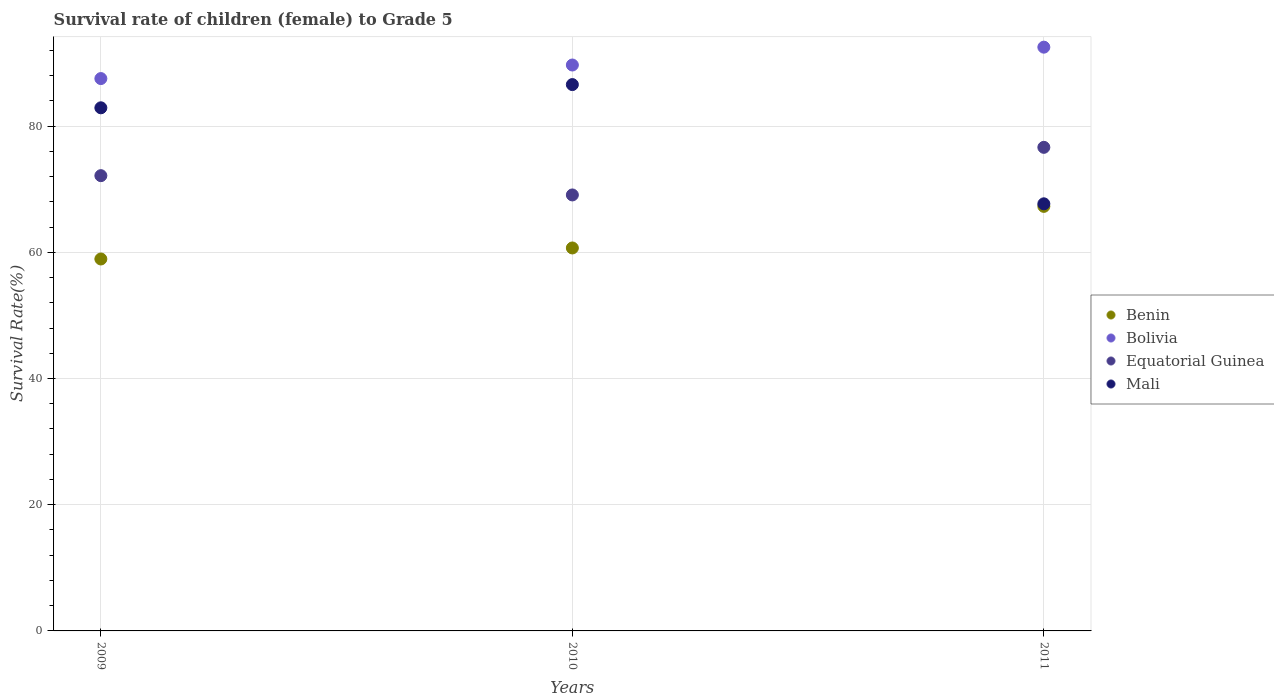What is the survival rate of female children to grade 5 in Bolivia in 2009?
Your answer should be very brief. 87.53. Across all years, what is the maximum survival rate of female children to grade 5 in Equatorial Guinea?
Make the answer very short. 76.63. Across all years, what is the minimum survival rate of female children to grade 5 in Mali?
Ensure brevity in your answer.  67.68. In which year was the survival rate of female children to grade 5 in Mali maximum?
Offer a terse response. 2010. In which year was the survival rate of female children to grade 5 in Mali minimum?
Give a very brief answer. 2011. What is the total survival rate of female children to grade 5 in Equatorial Guinea in the graph?
Provide a succinct answer. 217.86. What is the difference between the survival rate of female children to grade 5 in Mali in 2009 and that in 2010?
Give a very brief answer. -3.68. What is the difference between the survival rate of female children to grade 5 in Benin in 2010 and the survival rate of female children to grade 5 in Equatorial Guinea in 2009?
Your answer should be compact. -11.46. What is the average survival rate of female children to grade 5 in Equatorial Guinea per year?
Your answer should be very brief. 72.62. In the year 2011, what is the difference between the survival rate of female children to grade 5 in Benin and survival rate of female children to grade 5 in Bolivia?
Provide a short and direct response. -25.23. In how many years, is the survival rate of female children to grade 5 in Benin greater than 20 %?
Offer a terse response. 3. What is the ratio of the survival rate of female children to grade 5 in Mali in 2009 to that in 2011?
Your answer should be very brief. 1.22. What is the difference between the highest and the second highest survival rate of female children to grade 5 in Mali?
Provide a short and direct response. 3.68. What is the difference between the highest and the lowest survival rate of female children to grade 5 in Bolivia?
Ensure brevity in your answer.  4.98. Does the survival rate of female children to grade 5 in Benin monotonically increase over the years?
Give a very brief answer. Yes. Are the values on the major ticks of Y-axis written in scientific E-notation?
Ensure brevity in your answer.  No. Does the graph contain any zero values?
Give a very brief answer. No. How many legend labels are there?
Your response must be concise. 4. What is the title of the graph?
Ensure brevity in your answer.  Survival rate of children (female) to Grade 5. What is the label or title of the X-axis?
Offer a very short reply. Years. What is the label or title of the Y-axis?
Make the answer very short. Survival Rate(%). What is the Survival Rate(%) of Benin in 2009?
Your response must be concise. 58.94. What is the Survival Rate(%) of Bolivia in 2009?
Offer a terse response. 87.53. What is the Survival Rate(%) in Equatorial Guinea in 2009?
Give a very brief answer. 72.14. What is the Survival Rate(%) of Mali in 2009?
Your answer should be very brief. 82.9. What is the Survival Rate(%) of Benin in 2010?
Provide a succinct answer. 60.68. What is the Survival Rate(%) of Bolivia in 2010?
Ensure brevity in your answer.  89.68. What is the Survival Rate(%) of Equatorial Guinea in 2010?
Make the answer very short. 69.09. What is the Survival Rate(%) of Mali in 2010?
Provide a short and direct response. 86.57. What is the Survival Rate(%) in Benin in 2011?
Offer a terse response. 67.28. What is the Survival Rate(%) of Bolivia in 2011?
Ensure brevity in your answer.  92.5. What is the Survival Rate(%) in Equatorial Guinea in 2011?
Make the answer very short. 76.63. What is the Survival Rate(%) of Mali in 2011?
Provide a short and direct response. 67.68. Across all years, what is the maximum Survival Rate(%) in Benin?
Your answer should be compact. 67.28. Across all years, what is the maximum Survival Rate(%) in Bolivia?
Provide a short and direct response. 92.5. Across all years, what is the maximum Survival Rate(%) of Equatorial Guinea?
Provide a short and direct response. 76.63. Across all years, what is the maximum Survival Rate(%) in Mali?
Make the answer very short. 86.57. Across all years, what is the minimum Survival Rate(%) in Benin?
Offer a terse response. 58.94. Across all years, what is the minimum Survival Rate(%) of Bolivia?
Offer a very short reply. 87.53. Across all years, what is the minimum Survival Rate(%) of Equatorial Guinea?
Keep it short and to the point. 69.09. Across all years, what is the minimum Survival Rate(%) of Mali?
Offer a terse response. 67.68. What is the total Survival Rate(%) in Benin in the graph?
Keep it short and to the point. 186.9. What is the total Survival Rate(%) of Bolivia in the graph?
Offer a terse response. 269.71. What is the total Survival Rate(%) in Equatorial Guinea in the graph?
Your response must be concise. 217.86. What is the total Survival Rate(%) in Mali in the graph?
Give a very brief answer. 237.15. What is the difference between the Survival Rate(%) in Benin in 2009 and that in 2010?
Offer a terse response. -1.75. What is the difference between the Survival Rate(%) in Bolivia in 2009 and that in 2010?
Your answer should be compact. -2.15. What is the difference between the Survival Rate(%) in Equatorial Guinea in 2009 and that in 2010?
Your answer should be compact. 3.05. What is the difference between the Survival Rate(%) of Mali in 2009 and that in 2010?
Make the answer very short. -3.68. What is the difference between the Survival Rate(%) in Benin in 2009 and that in 2011?
Your answer should be compact. -8.34. What is the difference between the Survival Rate(%) of Bolivia in 2009 and that in 2011?
Keep it short and to the point. -4.98. What is the difference between the Survival Rate(%) in Equatorial Guinea in 2009 and that in 2011?
Give a very brief answer. -4.49. What is the difference between the Survival Rate(%) in Mali in 2009 and that in 2011?
Your response must be concise. 15.21. What is the difference between the Survival Rate(%) of Benin in 2010 and that in 2011?
Ensure brevity in your answer.  -6.59. What is the difference between the Survival Rate(%) of Bolivia in 2010 and that in 2011?
Make the answer very short. -2.83. What is the difference between the Survival Rate(%) in Equatorial Guinea in 2010 and that in 2011?
Offer a very short reply. -7.54. What is the difference between the Survival Rate(%) of Mali in 2010 and that in 2011?
Provide a succinct answer. 18.89. What is the difference between the Survival Rate(%) in Benin in 2009 and the Survival Rate(%) in Bolivia in 2010?
Keep it short and to the point. -30.74. What is the difference between the Survival Rate(%) in Benin in 2009 and the Survival Rate(%) in Equatorial Guinea in 2010?
Offer a terse response. -10.15. What is the difference between the Survival Rate(%) in Benin in 2009 and the Survival Rate(%) in Mali in 2010?
Keep it short and to the point. -27.64. What is the difference between the Survival Rate(%) of Bolivia in 2009 and the Survival Rate(%) of Equatorial Guinea in 2010?
Offer a terse response. 18.44. What is the difference between the Survival Rate(%) in Bolivia in 2009 and the Survival Rate(%) in Mali in 2010?
Your answer should be compact. 0.95. What is the difference between the Survival Rate(%) of Equatorial Guinea in 2009 and the Survival Rate(%) of Mali in 2010?
Your response must be concise. -14.43. What is the difference between the Survival Rate(%) in Benin in 2009 and the Survival Rate(%) in Bolivia in 2011?
Your response must be concise. -33.57. What is the difference between the Survival Rate(%) in Benin in 2009 and the Survival Rate(%) in Equatorial Guinea in 2011?
Your answer should be very brief. -17.69. What is the difference between the Survival Rate(%) of Benin in 2009 and the Survival Rate(%) of Mali in 2011?
Give a very brief answer. -8.74. What is the difference between the Survival Rate(%) of Bolivia in 2009 and the Survival Rate(%) of Equatorial Guinea in 2011?
Provide a succinct answer. 10.9. What is the difference between the Survival Rate(%) of Bolivia in 2009 and the Survival Rate(%) of Mali in 2011?
Your response must be concise. 19.85. What is the difference between the Survival Rate(%) of Equatorial Guinea in 2009 and the Survival Rate(%) of Mali in 2011?
Offer a very short reply. 4.46. What is the difference between the Survival Rate(%) in Benin in 2010 and the Survival Rate(%) in Bolivia in 2011?
Your response must be concise. -31.82. What is the difference between the Survival Rate(%) in Benin in 2010 and the Survival Rate(%) in Equatorial Guinea in 2011?
Your response must be concise. -15.95. What is the difference between the Survival Rate(%) in Benin in 2010 and the Survival Rate(%) in Mali in 2011?
Give a very brief answer. -7. What is the difference between the Survival Rate(%) in Bolivia in 2010 and the Survival Rate(%) in Equatorial Guinea in 2011?
Your answer should be very brief. 13.05. What is the difference between the Survival Rate(%) in Bolivia in 2010 and the Survival Rate(%) in Mali in 2011?
Provide a short and direct response. 22. What is the difference between the Survival Rate(%) of Equatorial Guinea in 2010 and the Survival Rate(%) of Mali in 2011?
Make the answer very short. 1.41. What is the average Survival Rate(%) in Benin per year?
Provide a short and direct response. 62.3. What is the average Survival Rate(%) of Bolivia per year?
Your answer should be compact. 89.9. What is the average Survival Rate(%) in Equatorial Guinea per year?
Make the answer very short. 72.62. What is the average Survival Rate(%) of Mali per year?
Your answer should be very brief. 79.05. In the year 2009, what is the difference between the Survival Rate(%) in Benin and Survival Rate(%) in Bolivia?
Provide a succinct answer. -28.59. In the year 2009, what is the difference between the Survival Rate(%) in Benin and Survival Rate(%) in Equatorial Guinea?
Provide a succinct answer. -13.2. In the year 2009, what is the difference between the Survival Rate(%) in Benin and Survival Rate(%) in Mali?
Provide a short and direct response. -23.96. In the year 2009, what is the difference between the Survival Rate(%) in Bolivia and Survival Rate(%) in Equatorial Guinea?
Your response must be concise. 15.39. In the year 2009, what is the difference between the Survival Rate(%) of Bolivia and Survival Rate(%) of Mali?
Your response must be concise. 4.63. In the year 2009, what is the difference between the Survival Rate(%) of Equatorial Guinea and Survival Rate(%) of Mali?
Offer a very short reply. -10.75. In the year 2010, what is the difference between the Survival Rate(%) in Benin and Survival Rate(%) in Bolivia?
Offer a very short reply. -28.99. In the year 2010, what is the difference between the Survival Rate(%) of Benin and Survival Rate(%) of Equatorial Guinea?
Offer a terse response. -8.4. In the year 2010, what is the difference between the Survival Rate(%) of Benin and Survival Rate(%) of Mali?
Your response must be concise. -25.89. In the year 2010, what is the difference between the Survival Rate(%) in Bolivia and Survival Rate(%) in Equatorial Guinea?
Provide a succinct answer. 20.59. In the year 2010, what is the difference between the Survival Rate(%) of Bolivia and Survival Rate(%) of Mali?
Your answer should be compact. 3.1. In the year 2010, what is the difference between the Survival Rate(%) in Equatorial Guinea and Survival Rate(%) in Mali?
Offer a terse response. -17.49. In the year 2011, what is the difference between the Survival Rate(%) in Benin and Survival Rate(%) in Bolivia?
Make the answer very short. -25.23. In the year 2011, what is the difference between the Survival Rate(%) in Benin and Survival Rate(%) in Equatorial Guinea?
Your response must be concise. -9.35. In the year 2011, what is the difference between the Survival Rate(%) of Benin and Survival Rate(%) of Mali?
Ensure brevity in your answer.  -0.4. In the year 2011, what is the difference between the Survival Rate(%) of Bolivia and Survival Rate(%) of Equatorial Guinea?
Ensure brevity in your answer.  15.87. In the year 2011, what is the difference between the Survival Rate(%) in Bolivia and Survival Rate(%) in Mali?
Give a very brief answer. 24.82. In the year 2011, what is the difference between the Survival Rate(%) of Equatorial Guinea and Survival Rate(%) of Mali?
Provide a short and direct response. 8.95. What is the ratio of the Survival Rate(%) in Benin in 2009 to that in 2010?
Give a very brief answer. 0.97. What is the ratio of the Survival Rate(%) in Equatorial Guinea in 2009 to that in 2010?
Provide a succinct answer. 1.04. What is the ratio of the Survival Rate(%) of Mali in 2009 to that in 2010?
Your response must be concise. 0.96. What is the ratio of the Survival Rate(%) of Benin in 2009 to that in 2011?
Your answer should be very brief. 0.88. What is the ratio of the Survival Rate(%) of Bolivia in 2009 to that in 2011?
Keep it short and to the point. 0.95. What is the ratio of the Survival Rate(%) in Equatorial Guinea in 2009 to that in 2011?
Offer a terse response. 0.94. What is the ratio of the Survival Rate(%) of Mali in 2009 to that in 2011?
Ensure brevity in your answer.  1.22. What is the ratio of the Survival Rate(%) of Benin in 2010 to that in 2011?
Your answer should be very brief. 0.9. What is the ratio of the Survival Rate(%) of Bolivia in 2010 to that in 2011?
Keep it short and to the point. 0.97. What is the ratio of the Survival Rate(%) of Equatorial Guinea in 2010 to that in 2011?
Offer a terse response. 0.9. What is the ratio of the Survival Rate(%) in Mali in 2010 to that in 2011?
Your response must be concise. 1.28. What is the difference between the highest and the second highest Survival Rate(%) of Benin?
Provide a short and direct response. 6.59. What is the difference between the highest and the second highest Survival Rate(%) of Bolivia?
Offer a very short reply. 2.83. What is the difference between the highest and the second highest Survival Rate(%) in Equatorial Guinea?
Your answer should be very brief. 4.49. What is the difference between the highest and the second highest Survival Rate(%) in Mali?
Your response must be concise. 3.68. What is the difference between the highest and the lowest Survival Rate(%) of Benin?
Your answer should be very brief. 8.34. What is the difference between the highest and the lowest Survival Rate(%) of Bolivia?
Offer a terse response. 4.98. What is the difference between the highest and the lowest Survival Rate(%) of Equatorial Guinea?
Keep it short and to the point. 7.54. What is the difference between the highest and the lowest Survival Rate(%) of Mali?
Make the answer very short. 18.89. 